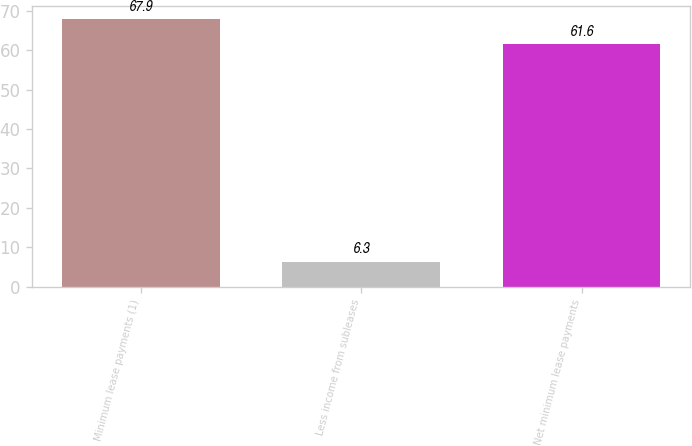Convert chart. <chart><loc_0><loc_0><loc_500><loc_500><bar_chart><fcel>Minimum lease payments (1)<fcel>Less income from subleases<fcel>Net minimum lease payments<nl><fcel>67.9<fcel>6.3<fcel>61.6<nl></chart> 